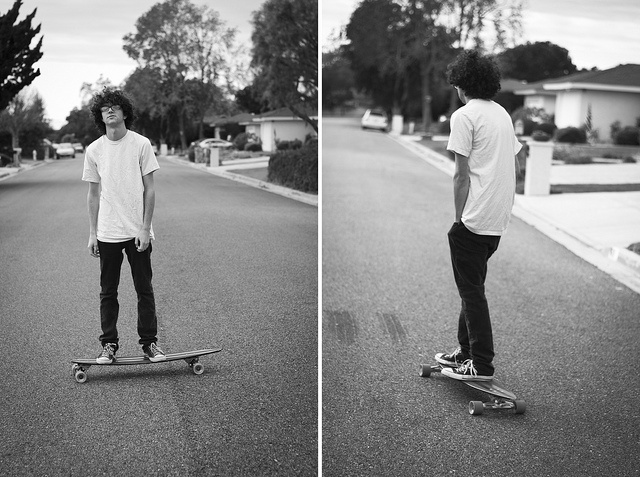Describe the objects in this image and their specific colors. I can see people in lightgray, black, gray, and darkgray tones, people in lightgray, black, darkgray, and gray tones, skateboard in lightgray, gray, black, and darkgray tones, skateboard in lightgray, gray, darkgray, and black tones, and car in lightgray, gainsboro, gray, darkgray, and black tones in this image. 